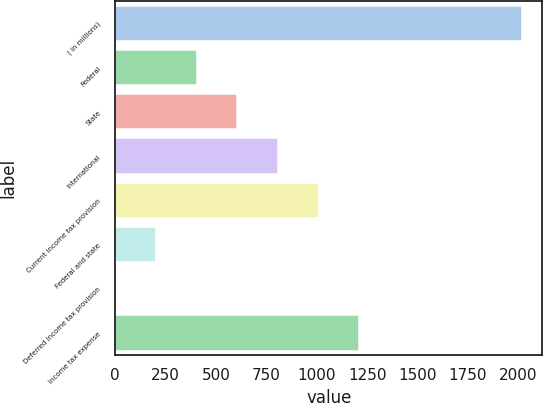<chart> <loc_0><loc_0><loc_500><loc_500><bar_chart><fcel>( in millions)<fcel>Federal<fcel>State<fcel>International<fcel>Current income tax provision<fcel>Federal and state<fcel>Deferred income tax provision<fcel>Income tax expense<nl><fcel>2018<fcel>404.32<fcel>606.03<fcel>807.74<fcel>1009.45<fcel>202.61<fcel>0.9<fcel>1211.16<nl></chart> 